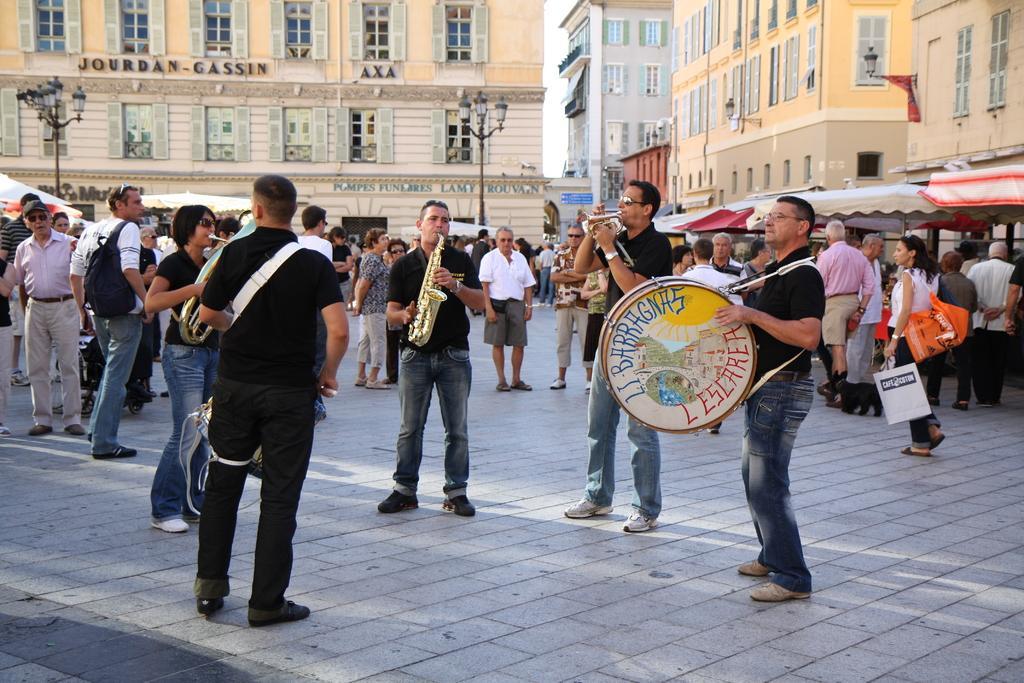How would you summarize this image in a sentence or two? In the image we can see there are lot of people who are standing and they are playing musical instruments. 